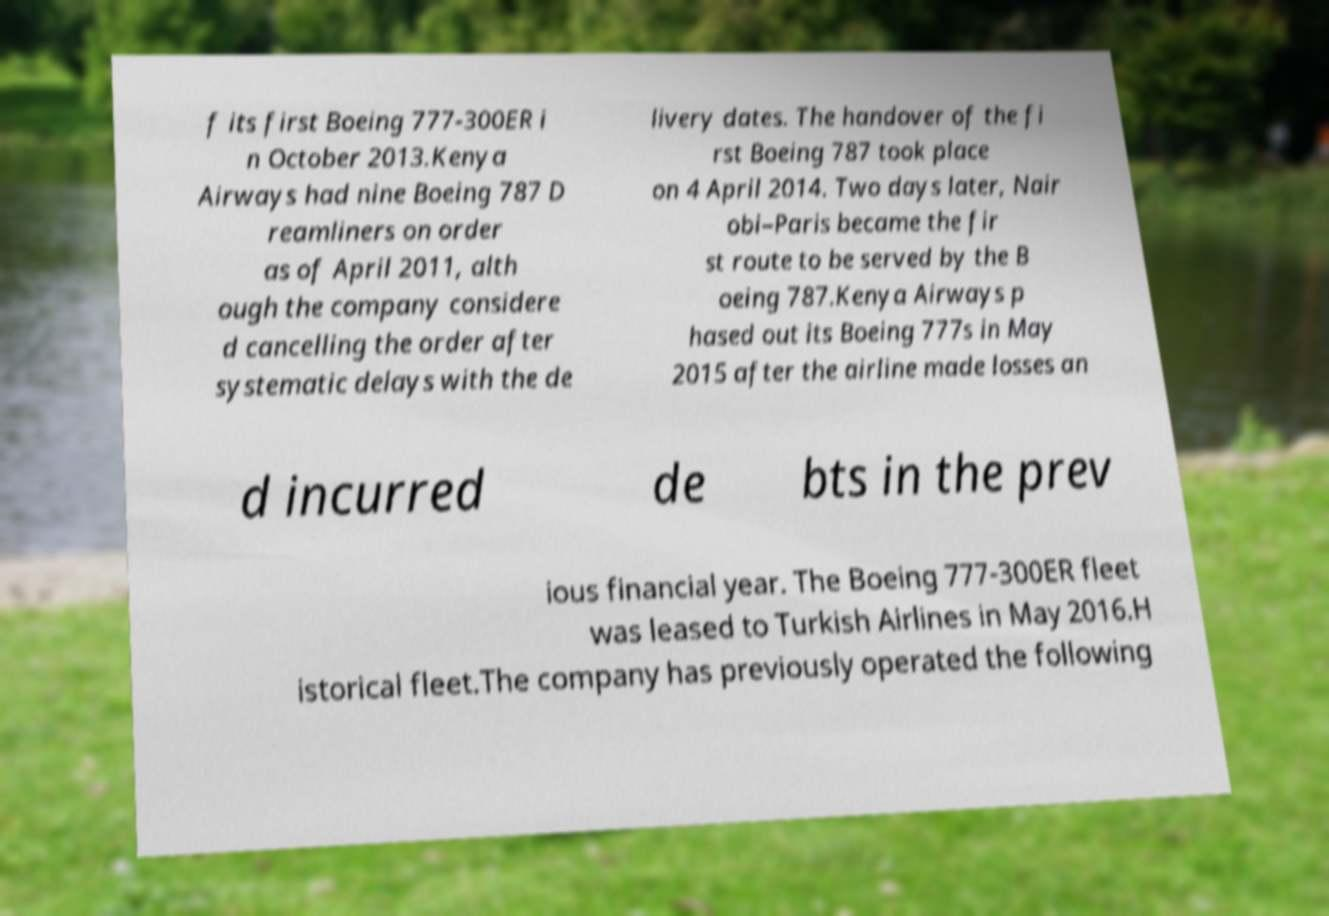I need the written content from this picture converted into text. Can you do that? f its first Boeing 777-300ER i n October 2013.Kenya Airways had nine Boeing 787 D reamliners on order as of April 2011, alth ough the company considere d cancelling the order after systematic delays with the de livery dates. The handover of the fi rst Boeing 787 took place on 4 April 2014. Two days later, Nair obi–Paris became the fir st route to be served by the B oeing 787.Kenya Airways p hased out its Boeing 777s in May 2015 after the airline made losses an d incurred de bts in the prev ious financial year. The Boeing 777-300ER fleet was leased to Turkish Airlines in May 2016.H istorical fleet.The company has previously operated the following 